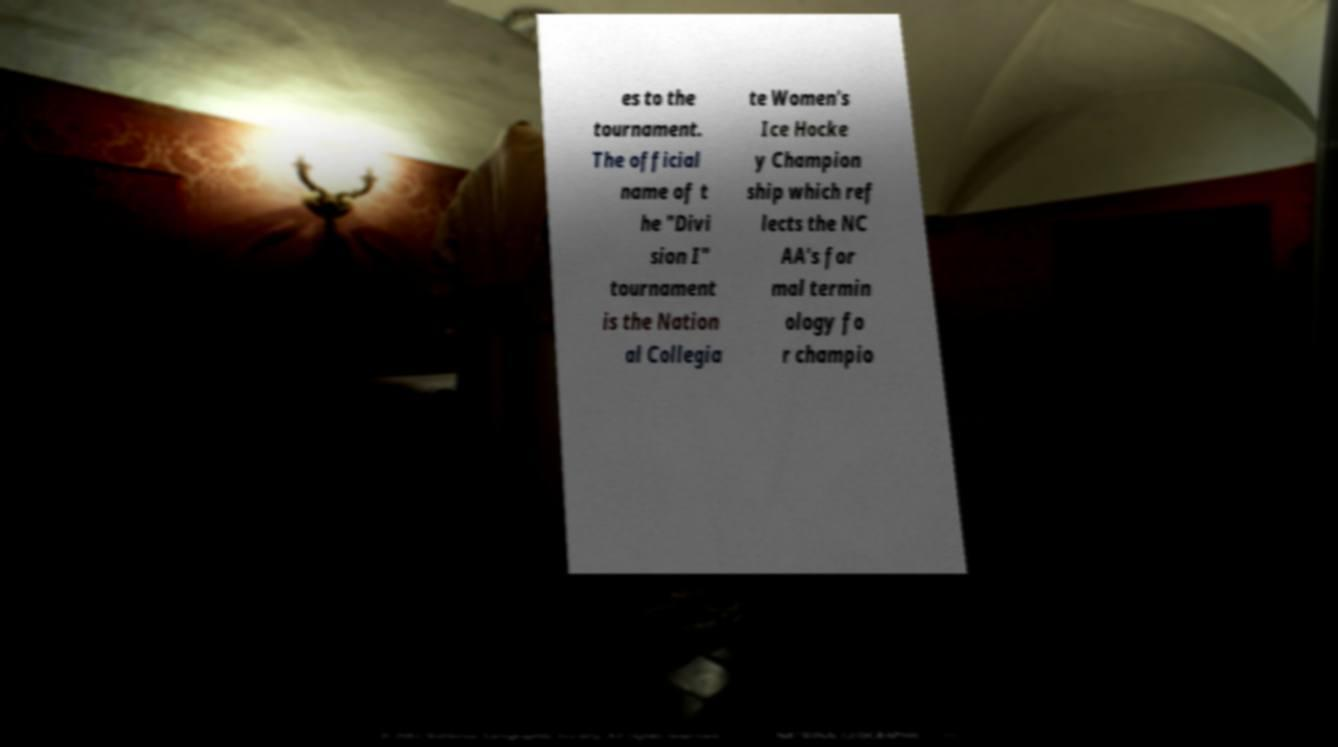Can you read and provide the text displayed in the image?This photo seems to have some interesting text. Can you extract and type it out for me? es to the tournament. The official name of t he "Divi sion I" tournament is the Nation al Collegia te Women's Ice Hocke y Champion ship which ref lects the NC AA's for mal termin ology fo r champio 